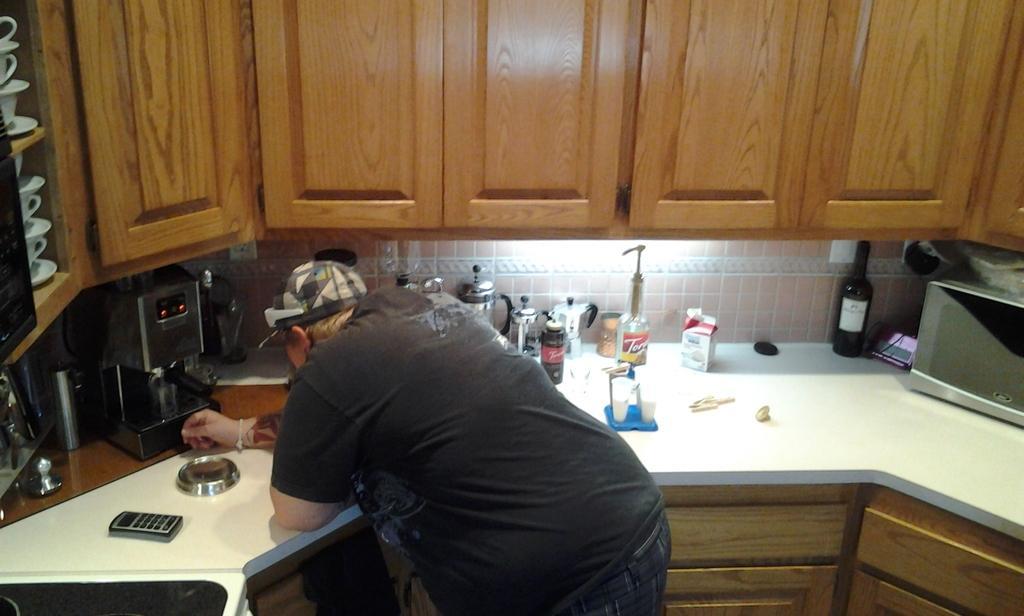In one or two sentences, can you explain what this image depicts? In this picture I can observe a person in the middle of the picture. He is standing in front of the desk. I can observe few things placed on the desk. I can observe brown color cupboards in this picture. 